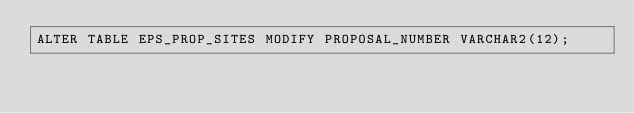Convert code to text. <code><loc_0><loc_0><loc_500><loc_500><_SQL_>ALTER TABLE EPS_PROP_SITES MODIFY PROPOSAL_NUMBER VARCHAR2(12);</code> 